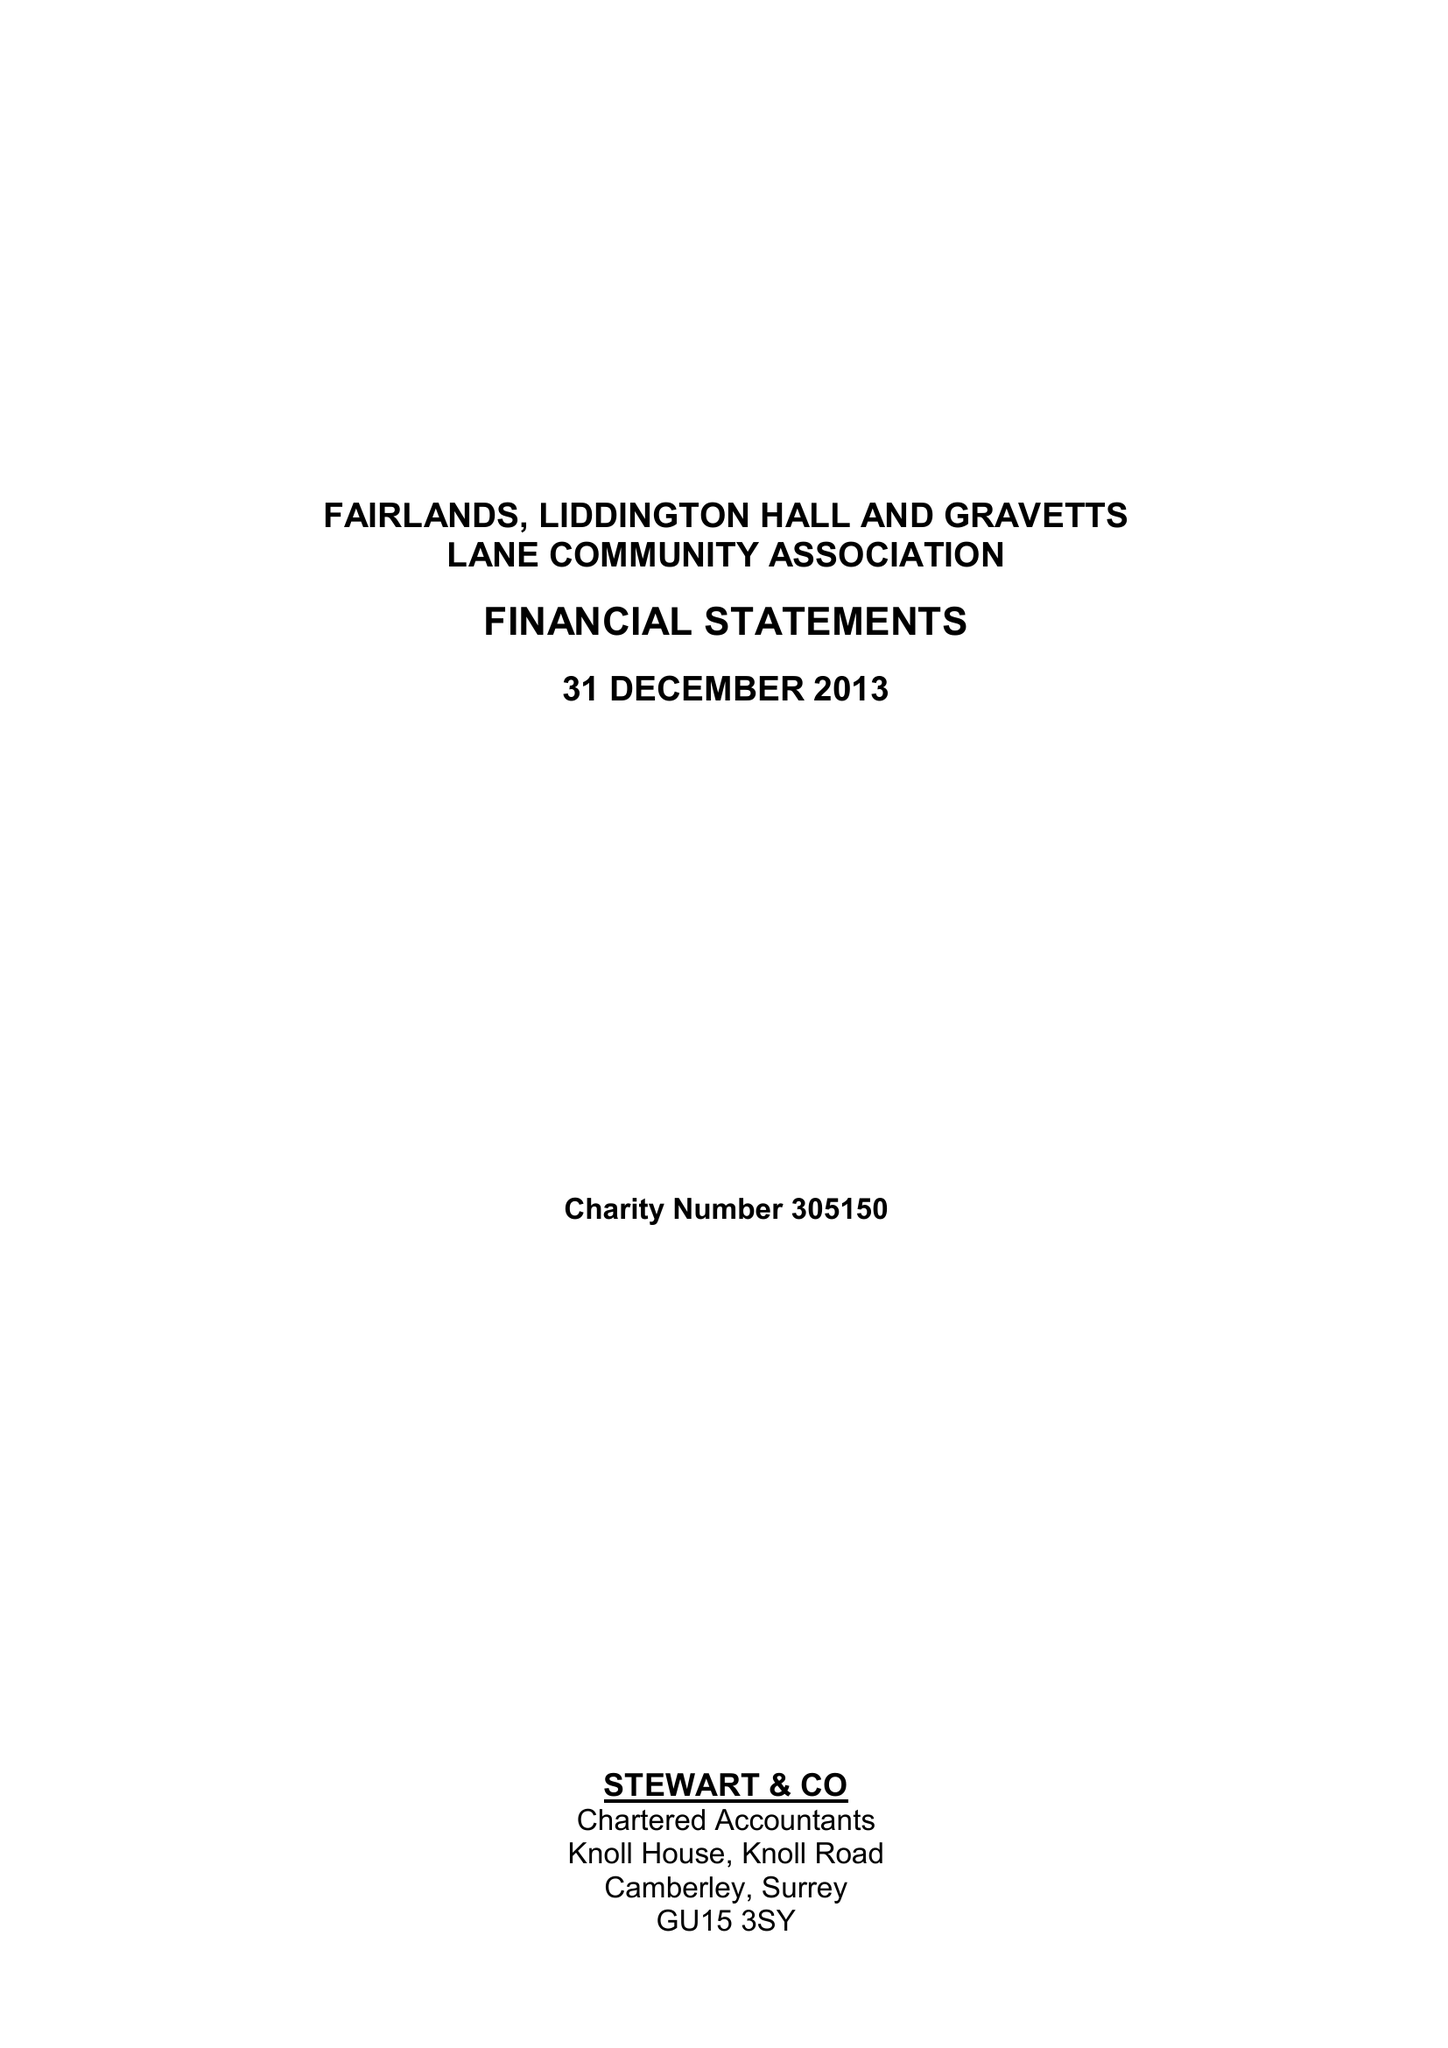What is the value for the spending_annually_in_british_pounds?
Answer the question using a single word or phrase. 44661.00 